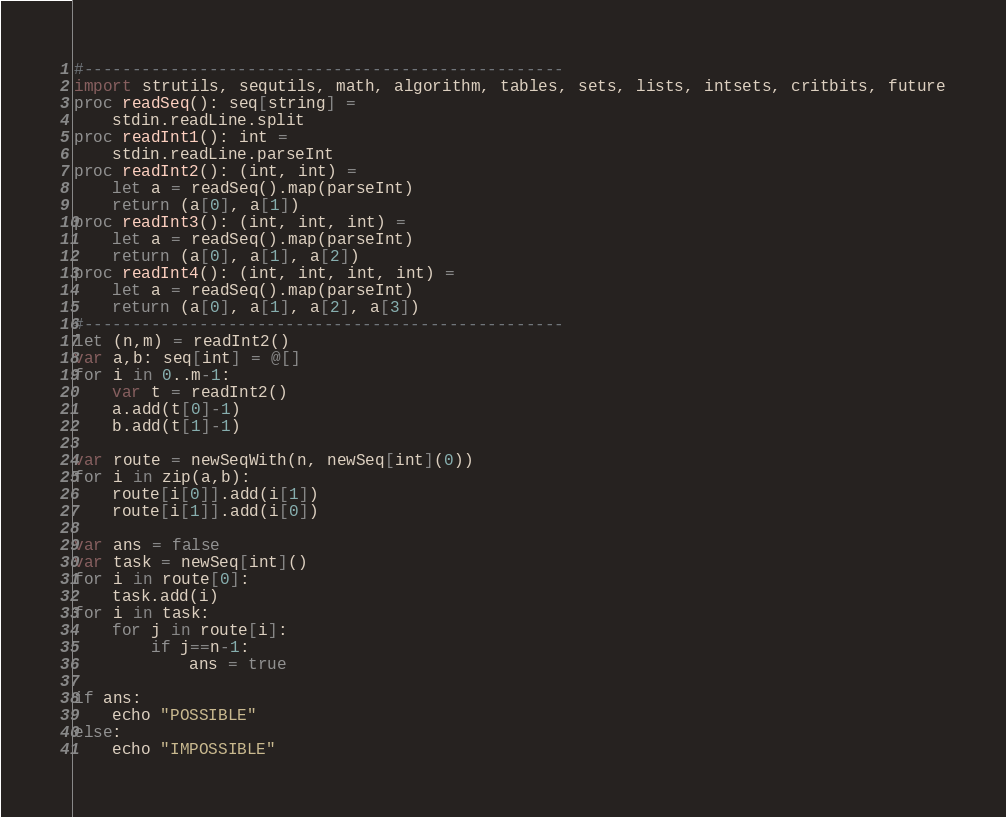Convert code to text. <code><loc_0><loc_0><loc_500><loc_500><_Nim_>#--------------------------------------------------
import strutils, sequtils, math, algorithm, tables, sets, lists, intsets, critbits, future
proc readSeq(): seq[string] =
    stdin.readLine.split
proc readInt1(): int =
    stdin.readLine.parseInt
proc readInt2(): (int, int) =
    let a = readSeq().map(parseInt)
    return (a[0], a[1])
proc readInt3(): (int, int, int) =
    let a = readSeq().map(parseInt)
    return (a[0], a[1], a[2])
proc readInt4(): (int, int, int, int) =
    let a = readSeq().map(parseInt)
    return (a[0], a[1], a[2], a[3])
#--------------------------------------------------
let (n,m) = readInt2()
var a,b: seq[int] = @[]
for i in 0..m-1:
    var t = readInt2()
    a.add(t[0]-1)
    b.add(t[1]-1)

var route = newSeqWith(n, newSeq[int](0))
for i in zip(a,b):
    route[i[0]].add(i[1])
    route[i[1]].add(i[0])

var ans = false
var task = newSeq[int]()
for i in route[0]:
    task.add(i)
for i in task:
    for j in route[i]:
        if j==n-1:
            ans = true

if ans:
    echo "POSSIBLE"
else:
    echo "IMPOSSIBLE"
</code> 